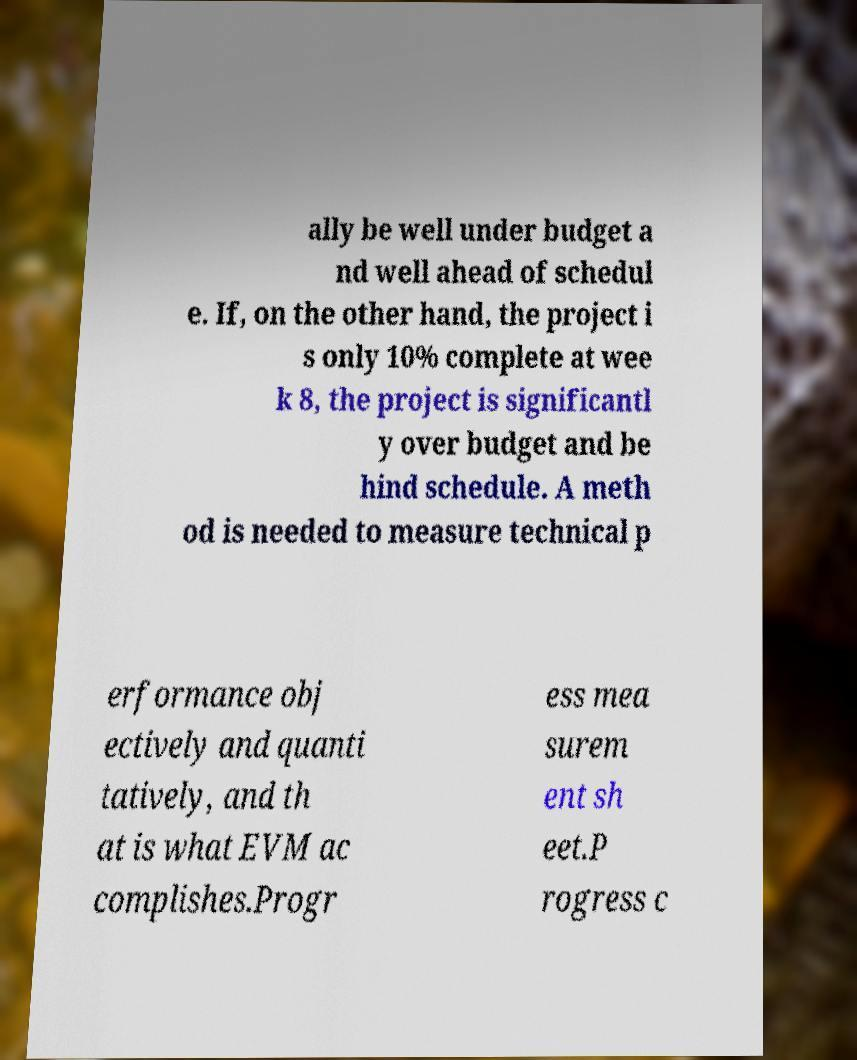Please identify and transcribe the text found in this image. ally be well under budget a nd well ahead of schedul e. If, on the other hand, the project i s only 10% complete at wee k 8, the project is significantl y over budget and be hind schedule. A meth od is needed to measure technical p erformance obj ectively and quanti tatively, and th at is what EVM ac complishes.Progr ess mea surem ent sh eet.P rogress c 